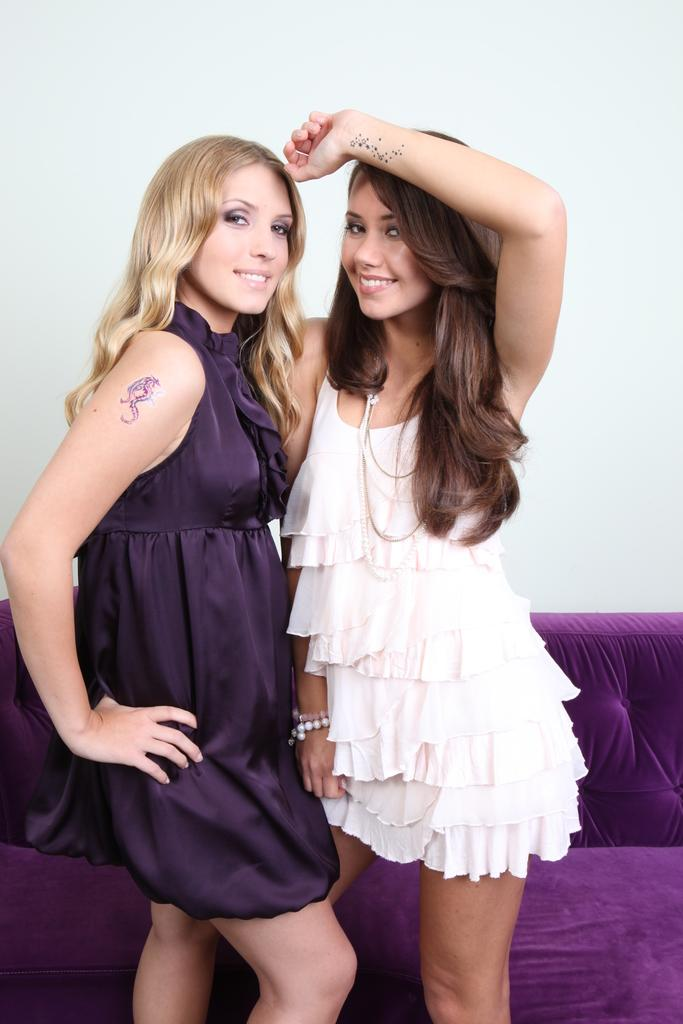How many people are in the image? There are two women standing in the image. What can be seen in the background of the image? There is a couch and a white-colored wall in the background of the image. What is the color of the couch? The couch is purple in color. What type of wax is being used by the women in the image? There is no wax present in the image, and the women are not using any wax. Can you tell me how the women are preparing for their flight in the image? There is no indication of a flight or any preparations for a flight in the image. 